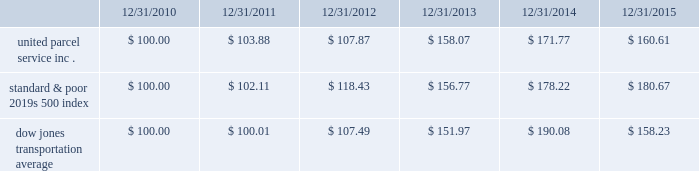Shareowner return performance graph the following performance graph and related information shall not be deemed 201csoliciting material 201d or to be 201cfiled 201d with the sec , nor shall such information be incorporated by reference into any future filing under the securities act of 1933 or securities exchange act of 1934 , each as amended , except to the extent that the company specifically incorporates such information by reference into such filing .
The following graph shows a five year comparison of cumulative total shareowners 2019 returns for our class b common stock , the standard & poor 2019s 500 index , and the dow jones transportation average .
The comparison of the total cumulative return on investment , which is the change in the quarterly stock price plus reinvested dividends for each of the quarterly periods , assumes that $ 100 was invested on december 31 , 2010 in the standard & poor 2019s 500 index , the dow jones transportation average , and our class b common stock. .

What was the difference in percentage total cumulative return on investment for united parcel service inc . compared to the standard & poor 2019s 500 index the for the five year period ending 12/31/2015? 
Computations: (((160.61 - 100) / 100) - ((180.67 - 100) / 100))
Answer: -0.2006. 